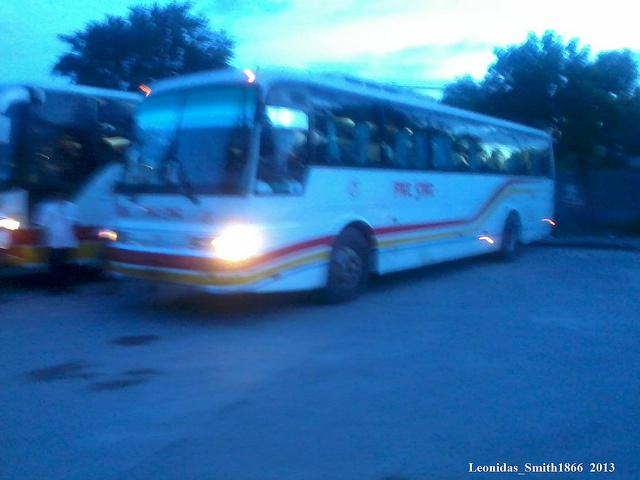Describe the objects in this image and their specific colors. I can see bus in cyan, blue, lightblue, and navy tones, bus in cyan, navy, black, blue, and lightblue tones, and people in cyan, black, blue, gray, and navy tones in this image. 